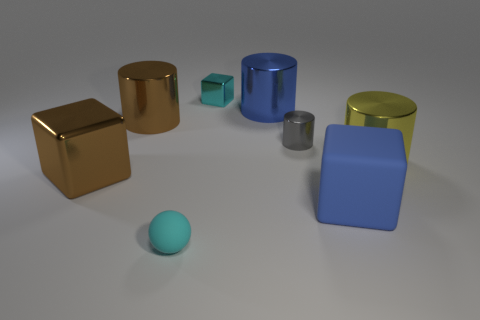There is a cyan cube that is the same size as the gray object; what is its material?
Your answer should be very brief. Metal. What number of objects are either green shiny spheres or cylinders?
Keep it short and to the point. 4. What number of cyan things are both in front of the brown cube and right of the cyan sphere?
Ensure brevity in your answer.  0. Are there fewer metal objects that are left of the big brown metallic cylinder than blue shiny cylinders?
Your response must be concise. No. There is a cyan thing that is the same size as the sphere; what is its shape?
Give a very brief answer. Cube. What number of other things are the same color as the tiny metal cylinder?
Your answer should be compact. 0. Is the size of the yellow thing the same as the cyan block?
Keep it short and to the point. No. How many things are either big red cubes or big cylinders that are right of the gray cylinder?
Your response must be concise. 1. Are there fewer big blocks in front of the blue cylinder than large blue shiny things that are to the left of the brown cylinder?
Give a very brief answer. No. What number of other things are the same material as the big yellow cylinder?
Your answer should be compact. 5. 